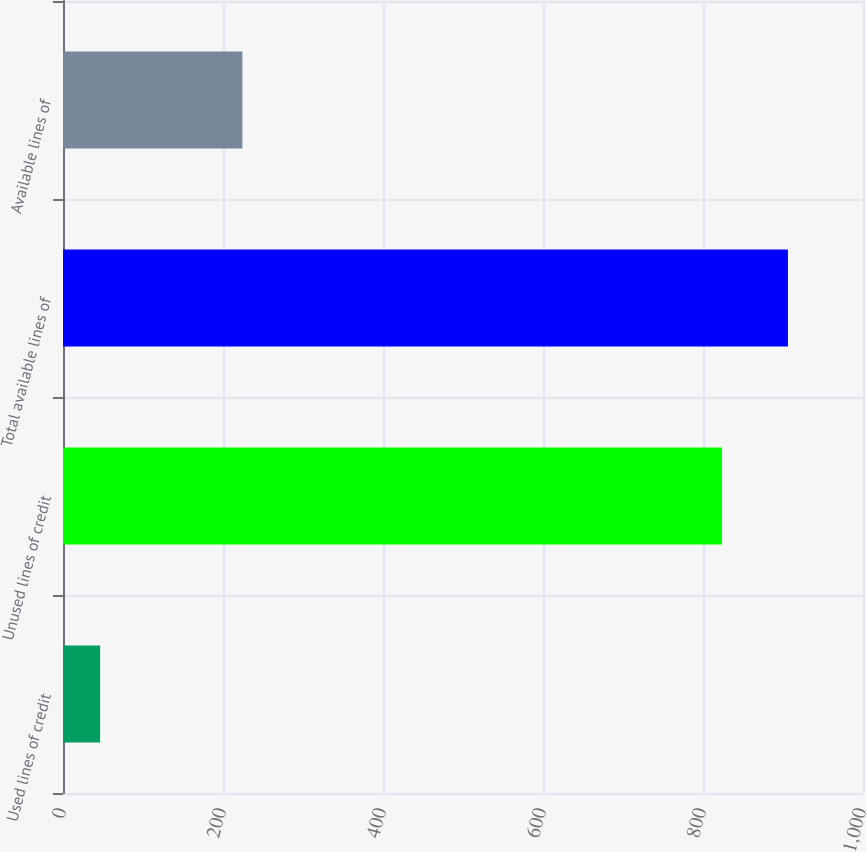<chart> <loc_0><loc_0><loc_500><loc_500><bar_chart><fcel>Used lines of credit<fcel>Unused lines of credit<fcel>Total available lines of<fcel>Available lines of<nl><fcel>46.4<fcel>823.8<fcel>906.18<fcel>224.2<nl></chart> 